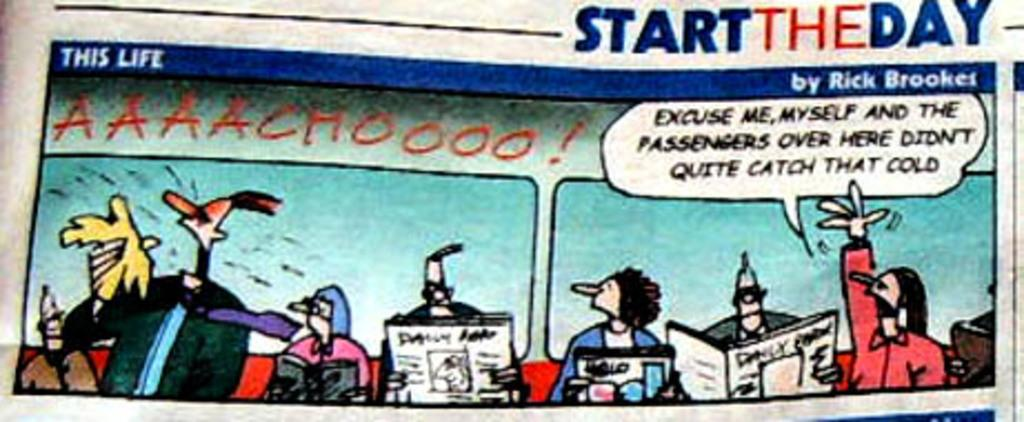<image>
Describe the image concisely. A This Life color comic strip by Rick Brookes 